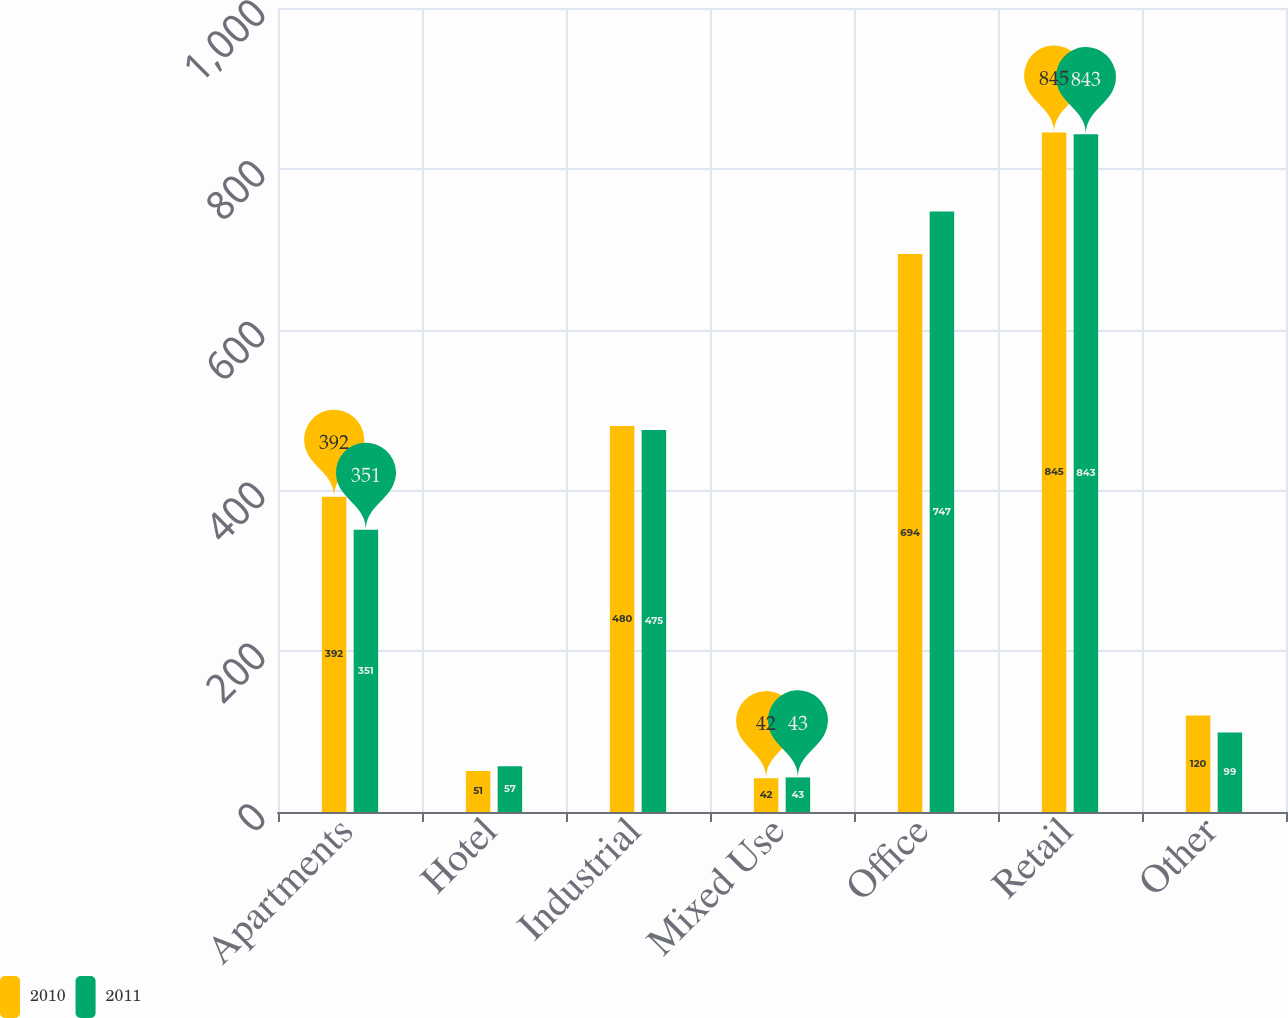<chart> <loc_0><loc_0><loc_500><loc_500><stacked_bar_chart><ecel><fcel>Apartments<fcel>Hotel<fcel>Industrial<fcel>Mixed Use<fcel>Office<fcel>Retail<fcel>Other<nl><fcel>2010<fcel>392<fcel>51<fcel>480<fcel>42<fcel>694<fcel>845<fcel>120<nl><fcel>2011<fcel>351<fcel>57<fcel>475<fcel>43<fcel>747<fcel>843<fcel>99<nl></chart> 